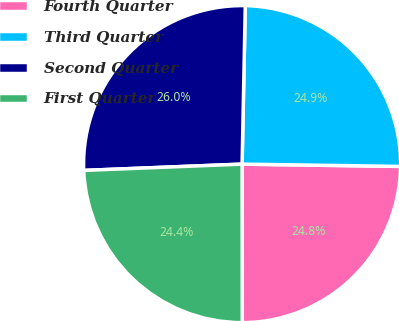Convert chart to OTSL. <chart><loc_0><loc_0><loc_500><loc_500><pie_chart><fcel>Fourth Quarter<fcel>Third Quarter<fcel>Second Quarter<fcel>First Quarter<nl><fcel>24.75%<fcel>24.91%<fcel>25.95%<fcel>24.38%<nl></chart> 